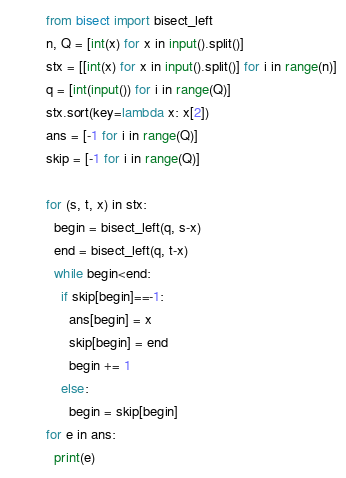<code> <loc_0><loc_0><loc_500><loc_500><_Python_>from bisect import bisect_left
n, Q = [int(x) for x in input().split()]
stx = [[int(x) for x in input().split()] for i in range(n)]
q = [int(input()) for i in range(Q)]
stx.sort(key=lambda x: x[2])
ans = [-1 for i in range(Q)]
skip = [-1 for i in range(Q)]

for (s, t, x) in stx:
  begin = bisect_left(q, s-x)
  end = bisect_left(q, t-x)
  while begin<end:
    if skip[begin]==-1:
      ans[begin] = x
      skip[begin] = end
      begin += 1
    else:
      begin = skip[begin]
for e in ans:
  print(e)</code> 